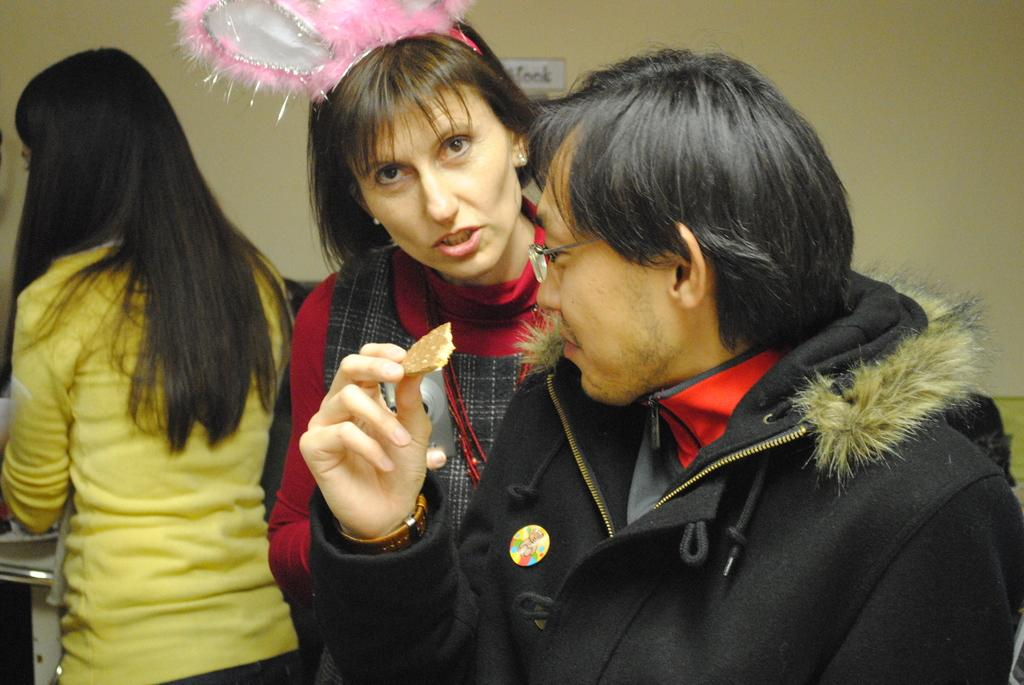How many people are present in the image? There are three people standing in the image. What is one of the people holding in his hand? One of the people is holding a biscuit in his hand. What can be seen in the background of the image? There is a wall in the background of the image. What type of jelly is being used to stick the calendar to the wall in the image? There is no calendar or jelly present in the image. Can you see a ray of light shining on the people in the image? The image does not show any rays of light shining on the people or any other objects in the image. 